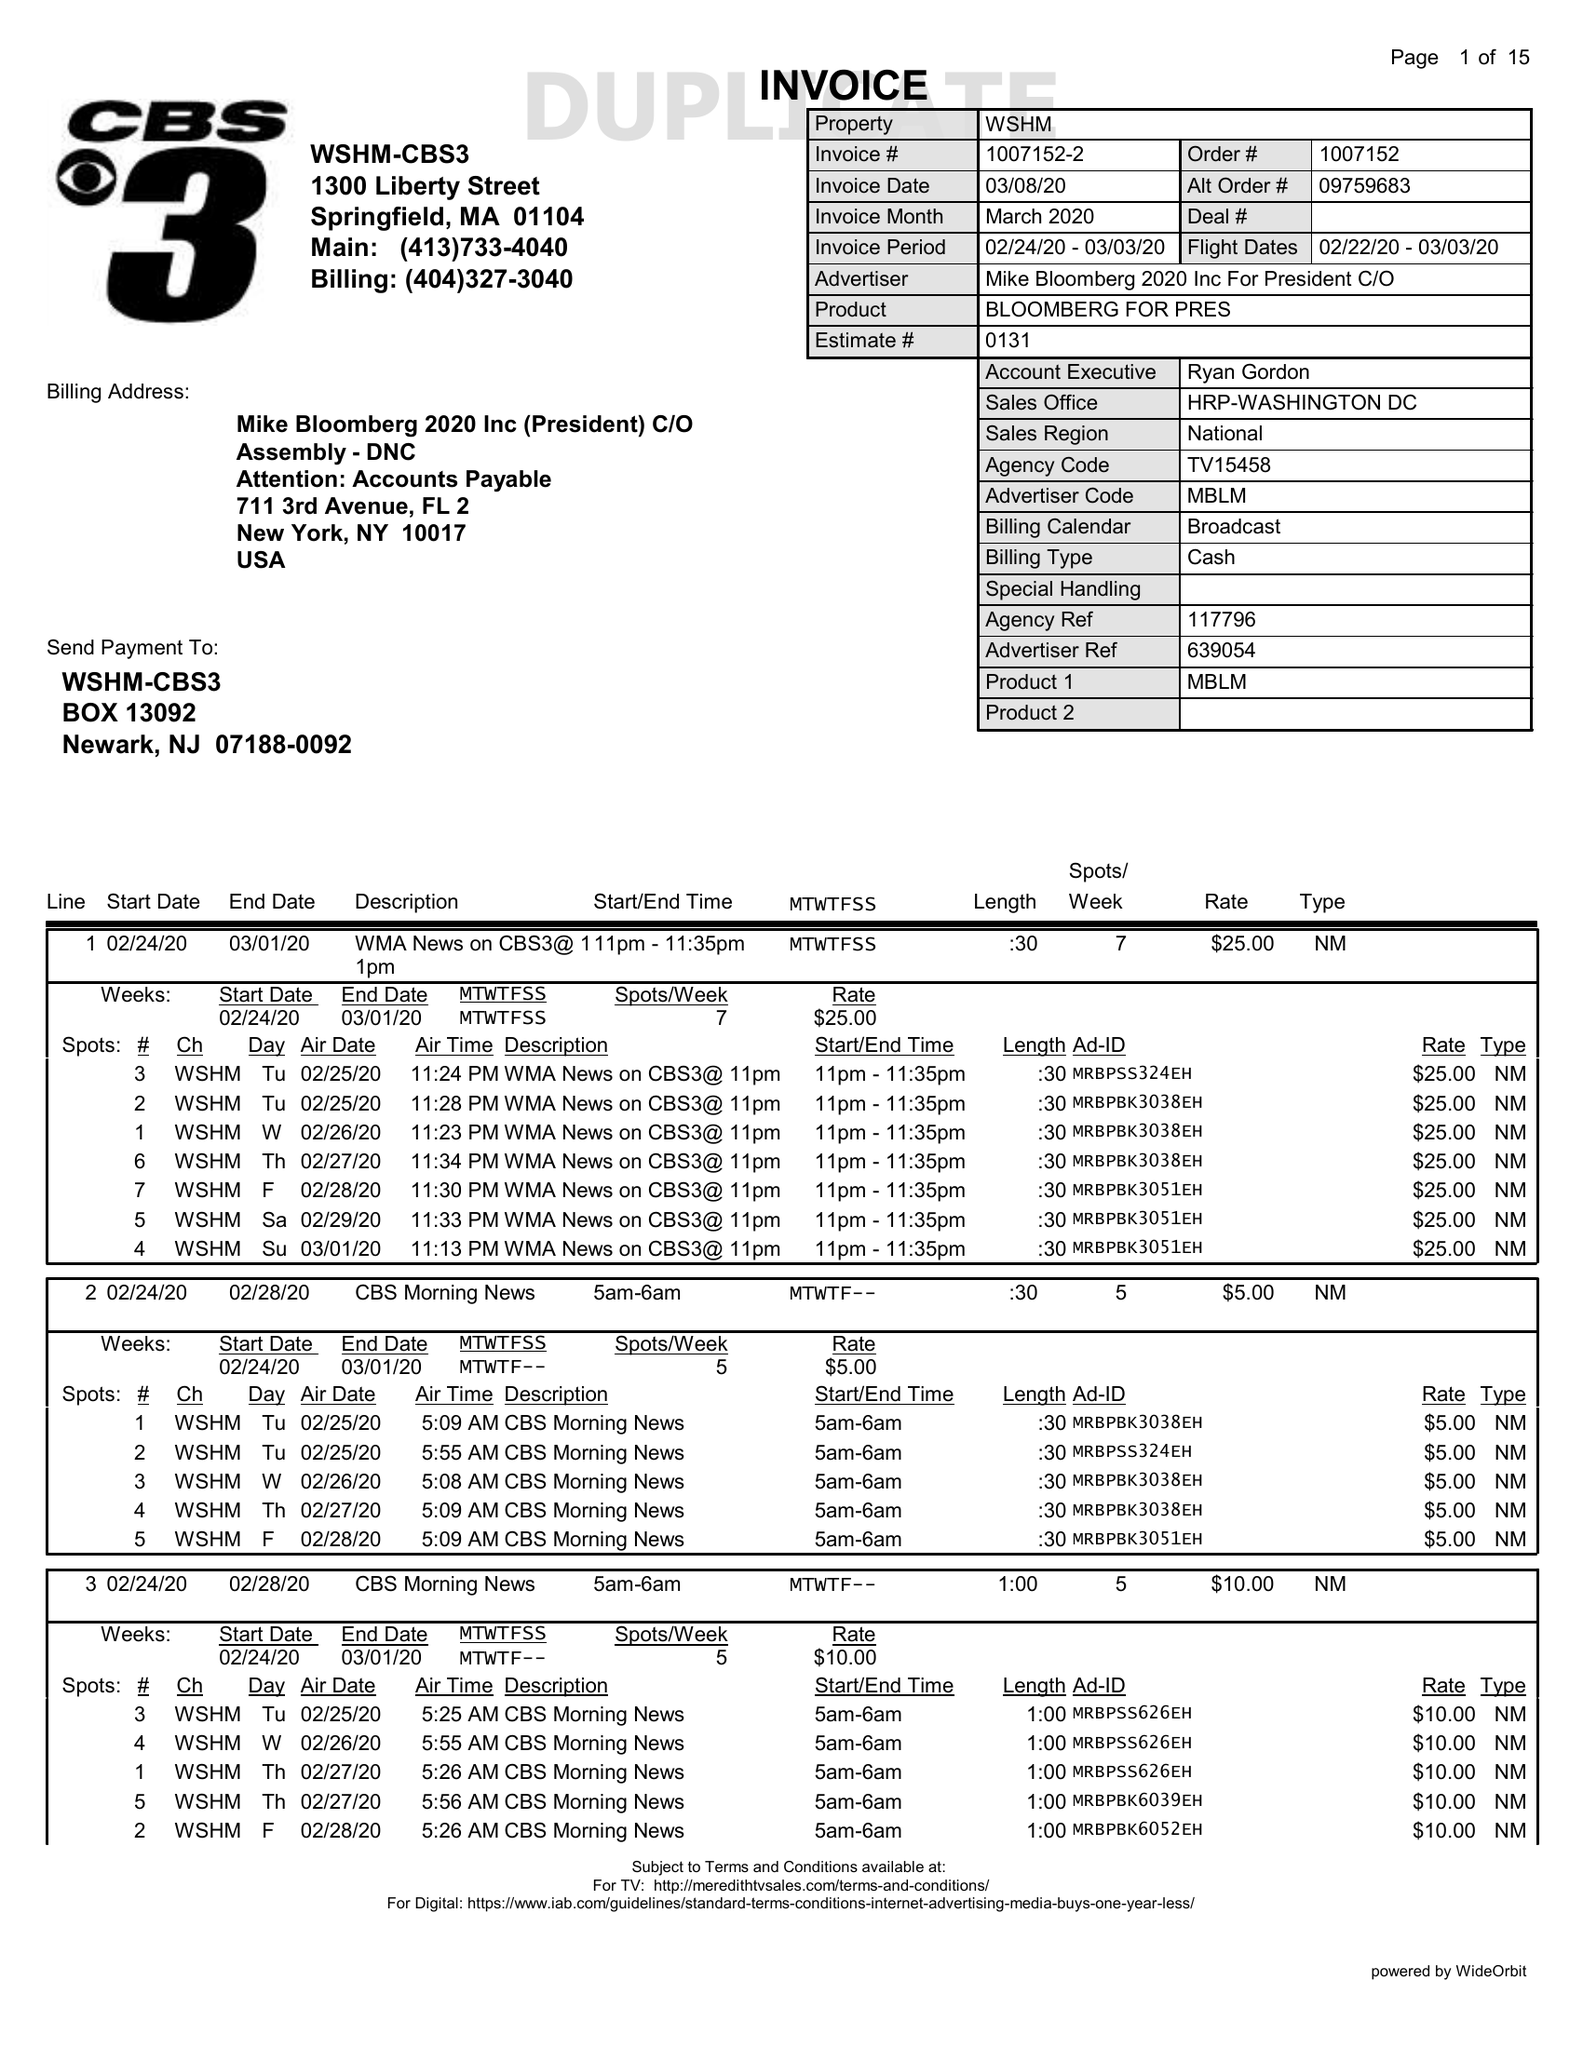What is the value for the gross_amount?
Answer the question using a single word or phrase. 12389.00 